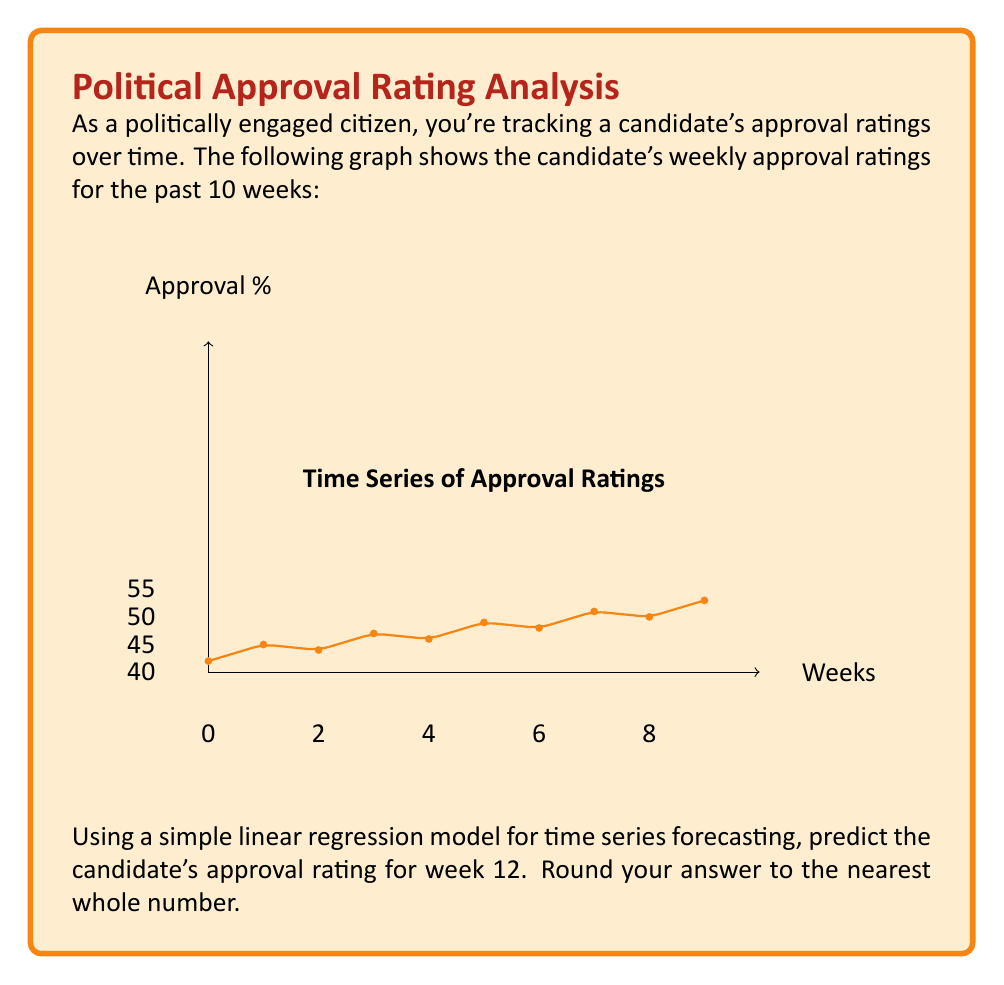Provide a solution to this math problem. To forecast the approval rating using a simple linear regression model, we'll follow these steps:

1) First, we need to calculate the slope (m) and y-intercept (b) of the line of best fit.

2) The formula for the slope is:

   $$m = \frac{n\sum(xy) - \sum x \sum y}{n\sum x^2 - (\sum x)^2}$$

   where n is the number of data points, x represents the weeks, and y represents the approval ratings.

3) The y-intercept is calculated using:

   $$b = \bar{y} - m\bar{x}$$

   where $\bar{x}$ and $\bar{y}$ are the means of x and y respectively.

4) Let's calculate the necessary sums:
   
   $n = 10$
   $\sum x = 0 + 1 + 2 + ... + 9 = 45$
   $\sum y = 42 + 45 + 44 + ... + 53 = 475$
   $\sum xy = 0(42) + 1(45) + 2(44) + ... + 9(53) = 2385$
   $\sum x^2 = 0^2 + 1^2 + 2^2 + ... + 9^2 = 285$

5) Now we can calculate the slope:

   $$m = \frac{10(2385) - 45(475)}{10(285) - 45^2} = \frac{23850 - 21375}{2850 - 2025} = \frac{2475}{825} = 3$$

6) Calculate the means:
   
   $\bar{x} = 45/10 = 4.5$
   $\bar{y} = 475/10 = 47.5$

7) Now we can calculate the y-intercept:

   $$b = 47.5 - 3(4.5) = 47.5 - 13.5 = 34$$

8) Our linear regression equation is therefore:

   $$y = 3x + 34$$

9) To predict the approval rating for week 12, we substitute x = 12:

   $$y = 3(12) + 34 = 36 + 34 = 70$$

10) Rounding to the nearest whole number, our prediction is 70%.
Answer: 70% 